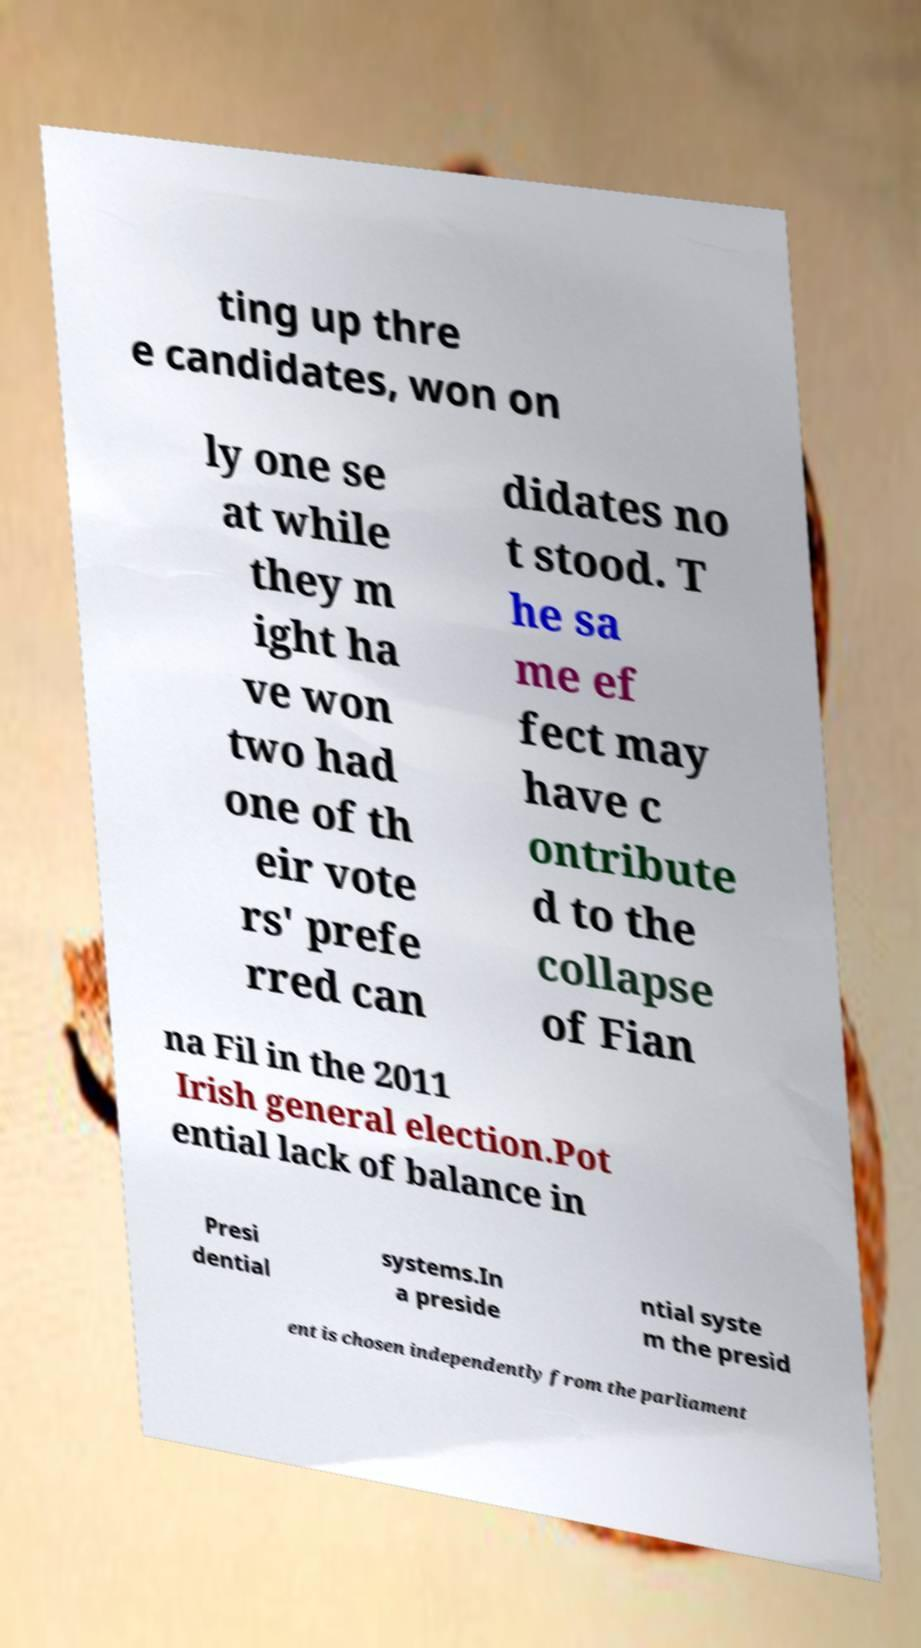What messages or text are displayed in this image? I need them in a readable, typed format. ting up thre e candidates, won on ly one se at while they m ight ha ve won two had one of th eir vote rs' prefe rred can didates no t stood. T he sa me ef fect may have c ontribute d to the collapse of Fian na Fil in the 2011 Irish general election.Pot ential lack of balance in Presi dential systems.In a preside ntial syste m the presid ent is chosen independently from the parliament 